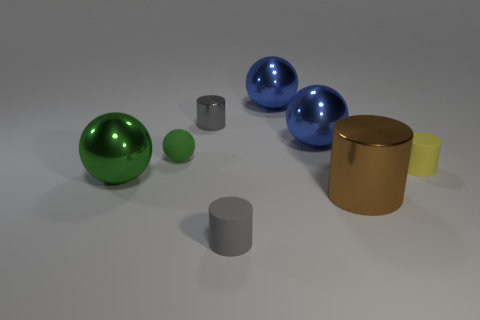Subtract all small spheres. How many spheres are left? 3 Subtract all blue spheres. How many spheres are left? 2 Subtract 3 cylinders. How many cylinders are left? 1 Add 1 tiny balls. How many objects exist? 9 Subtract all red balls. Subtract all cyan cylinders. How many balls are left? 4 Subtract all brown blocks. How many purple balls are left? 0 Subtract all purple metallic things. Subtract all rubber spheres. How many objects are left? 7 Add 3 metallic cylinders. How many metallic cylinders are left? 5 Add 1 tiny red matte spheres. How many tiny red matte spheres exist? 1 Subtract 0 red cubes. How many objects are left? 8 